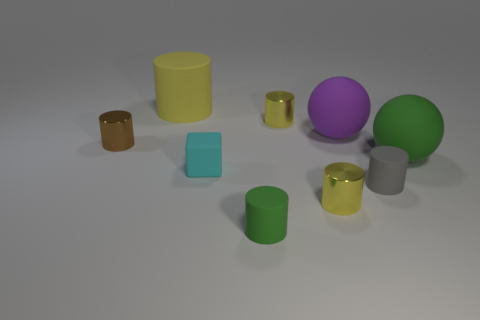How many purple balls are the same size as the purple matte object?
Provide a short and direct response. 0. Are there more large matte things right of the matte cube than big purple objects behind the brown object?
Keep it short and to the point. Yes. There is a cyan block that is the same size as the gray matte cylinder; what material is it?
Provide a succinct answer. Rubber. The small green thing has what shape?
Your response must be concise. Cylinder. What number of red things are either matte balls or cylinders?
Offer a very short reply. 0. What is the size of the yellow object that is the same material as the small gray cylinder?
Provide a succinct answer. Large. Are the ball that is in front of the tiny brown thing and the small cylinder that is behind the brown thing made of the same material?
Make the answer very short. No. What number of cylinders are tiny rubber things or gray matte things?
Offer a terse response. 2. There is a large yellow cylinder that is behind the small thing that is on the right side of the large purple ball; how many cylinders are on the left side of it?
Ensure brevity in your answer.  1. There is a green thing that is the same shape as the purple rubber thing; what is its material?
Offer a very short reply. Rubber. 